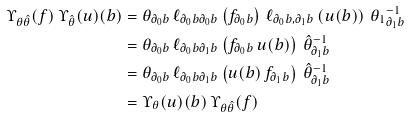Convert formula to latex. <formula><loc_0><loc_0><loc_500><loc_500>\Upsilon _ { \theta \hat { \theta } } ( f ) \, \Upsilon _ { \hat { \theta } } ( u ) ( b ) & = \theta _ { \partial _ { 0 } b } \, \ell _ { \partial _ { 0 } b \partial _ { 0 } b } \left ( f _ { \partial _ { 0 } b } \right ) \, \ell _ { \partial _ { 0 } b , \partial _ { 1 } b } \left ( u ( b ) \right ) \, { \theta _ { 1 } } ^ { - 1 } _ { \partial _ { 1 } b } \\ & = \theta _ { \partial _ { 0 } b } \, \ell _ { \partial _ { 0 } b \partial _ { 1 } b } \left ( f _ { \partial _ { 0 } b } \, u ( b ) \right ) \, { \hat { \theta } } ^ { - 1 } _ { \partial _ { 1 } b } \\ & = \theta _ { \partial _ { 0 } b } \, \ell _ { \partial _ { 0 } b \partial _ { 1 } b } \left ( u ( b ) \, f _ { \partial _ { 1 } b } \right ) \, { \hat { \theta } } ^ { - 1 } _ { \partial _ { 1 } b } \\ & = \Upsilon _ { \theta } ( u ) ( b ) \, \Upsilon _ { \theta \hat { \theta } } ( f ) \</formula> 